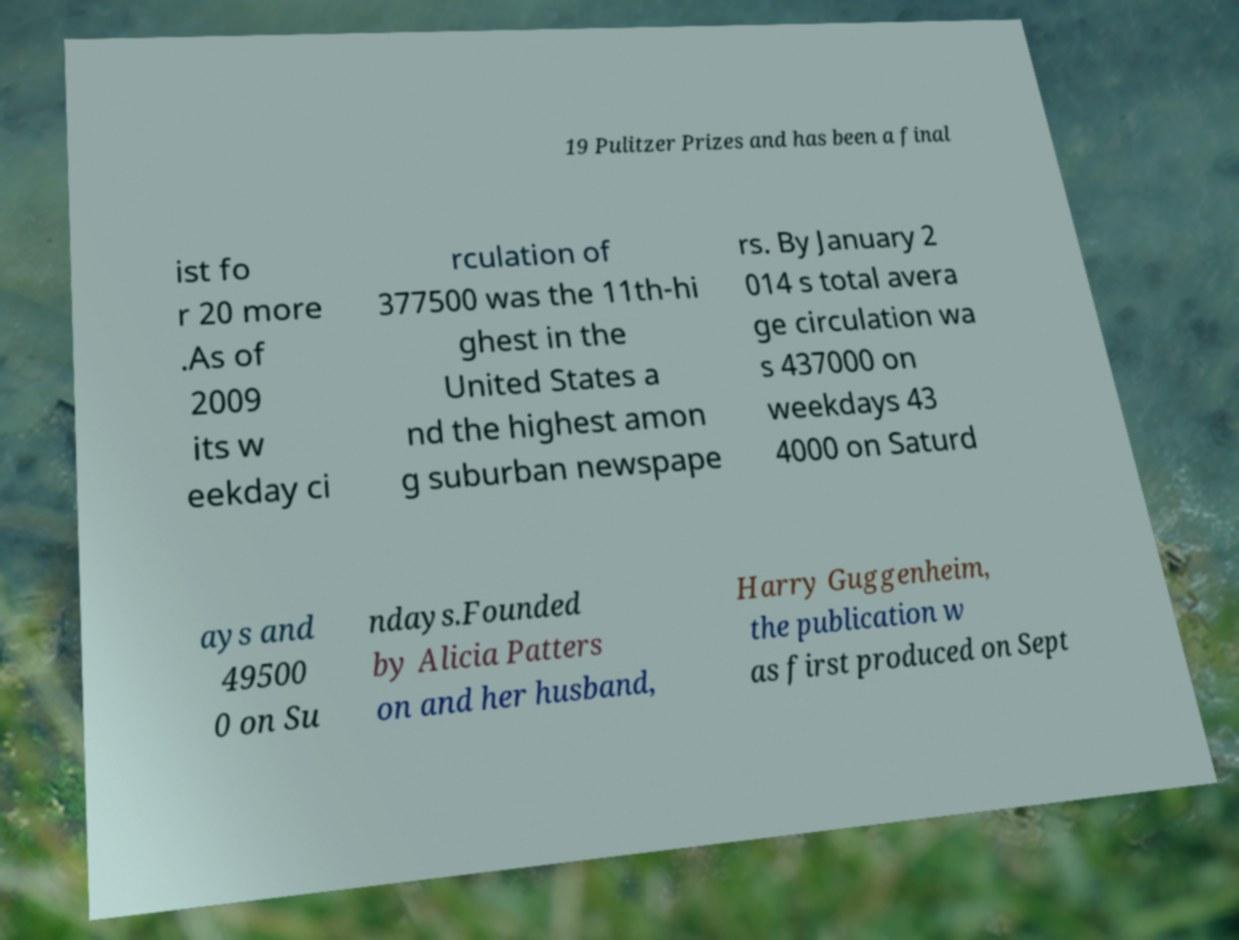Could you assist in decoding the text presented in this image and type it out clearly? 19 Pulitzer Prizes and has been a final ist fo r 20 more .As of 2009 its w eekday ci rculation of 377500 was the 11th-hi ghest in the United States a nd the highest amon g suburban newspape rs. By January 2 014 s total avera ge circulation wa s 437000 on weekdays 43 4000 on Saturd ays and 49500 0 on Su ndays.Founded by Alicia Patters on and her husband, Harry Guggenheim, the publication w as first produced on Sept 